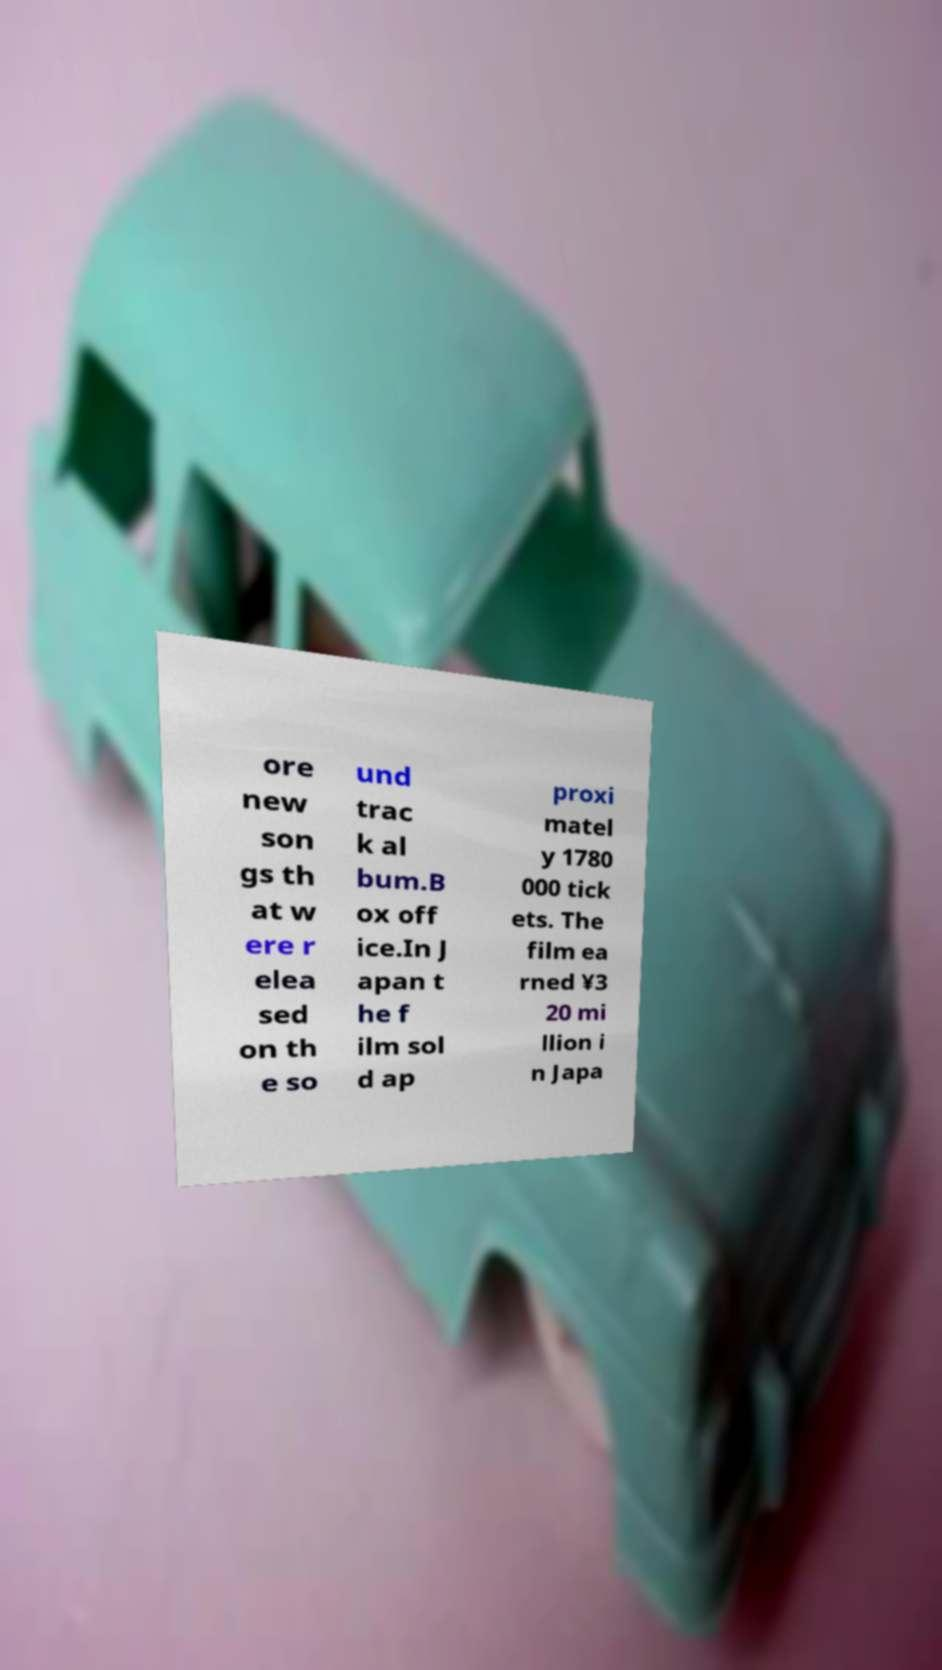Could you extract and type out the text from this image? ore new son gs th at w ere r elea sed on th e so und trac k al bum.B ox off ice.In J apan t he f ilm sol d ap proxi matel y 1780 000 tick ets. The film ea rned ¥3 20 mi llion i n Japa 